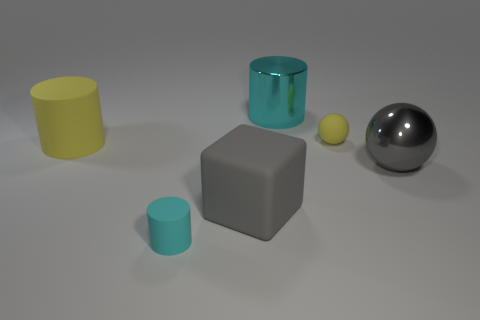Add 2 large brown matte cubes. How many objects exist? 8 Subtract all large cylinders. How many cylinders are left? 1 Subtract all gray balls. How many cyan cylinders are left? 2 Subtract all balls. How many objects are left? 4 Subtract all brown cylinders. Subtract all green cubes. How many cylinders are left? 3 Add 6 cyan blocks. How many cyan blocks exist? 6 Subtract 0 cyan cubes. How many objects are left? 6 Subtract all yellow things. Subtract all big matte cubes. How many objects are left? 3 Add 2 large yellow matte cylinders. How many large yellow matte cylinders are left? 3 